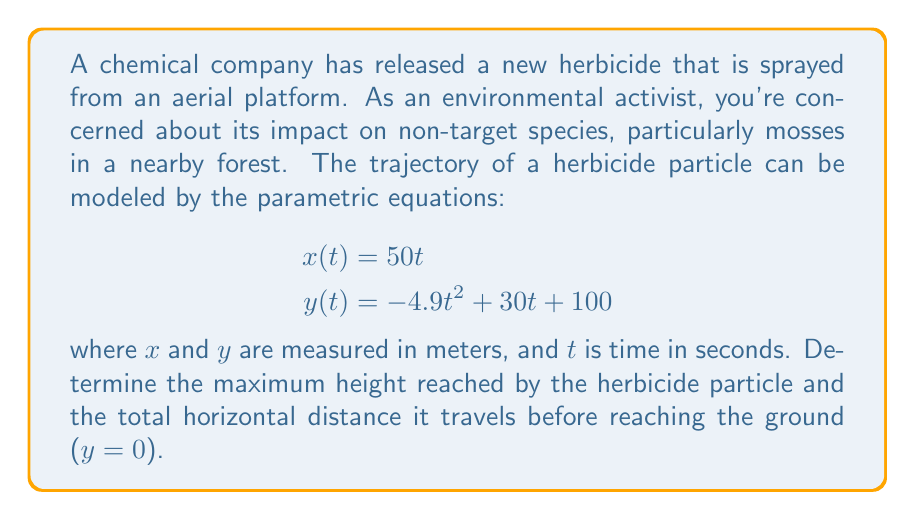Give your solution to this math problem. To solve this problem, we'll follow these steps:

1) Find the maximum height:
   The maximum height occurs when the vertical velocity is zero. We can find this by taking the derivative of y(t) with respect to t and setting it to zero.

   $$\frac{dy}{dt} = -9.8t + 30$$
   
   Set this equal to zero and solve for t:
   $$-9.8t + 30 = 0$$
   $$t = \frac{30}{9.8} \approx 3.06 \text{ seconds}$$

   Now, we can plug this t-value back into the y(t) equation:
   $$y(3.06) = -4.9(3.06)^2 + 30(3.06) + 100 \approx 145.92 \text{ meters}$$

2) Find the total horizontal distance:
   To find when the particle reaches the ground, we need to solve y(t) = 0:

   $$-4.9t^2 + 30t + 100 = 0$$

   This is a quadratic equation. We can solve it using the quadratic formula:
   $$t = \frac{-b \pm \sqrt{b^2 - 4ac}}{2a}$$

   Where $a = -4.9$, $b = 30$, and $c = 100$

   $$t = \frac{-30 \pm \sqrt{30^2 - 4(-4.9)(100)}}{2(-4.9)}$$

   This gives us two solutions: $t \approx -0.78$ and $t \approx 7.90$

   Since time can't be negative in this context, we use $t \approx 7.90$ seconds.

   Now we can find the horizontal distance by plugging this t-value into x(t):

   $$x(7.90) = 50(7.90) = 395 \text{ meters}$$
Answer: The herbicide particle reaches a maximum height of approximately 145.92 meters and travels a total horizontal distance of 395 meters before reaching the ground. 